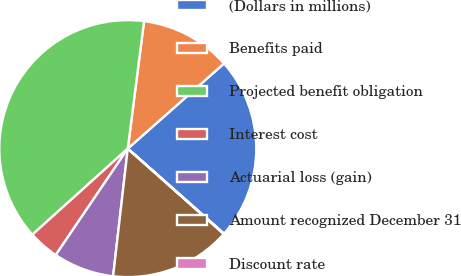<chart> <loc_0><loc_0><loc_500><loc_500><pie_chart><fcel>(Dollars in millions)<fcel>Benefits paid<fcel>Projected benefit obligation<fcel>Interest cost<fcel>Actuarial loss (gain)<fcel>Amount recognized December 31<fcel>Discount rate<nl><fcel>23.04%<fcel>11.45%<fcel>38.7%<fcel>3.85%<fcel>7.65%<fcel>15.25%<fcel>0.05%<nl></chart> 